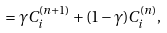<formula> <loc_0><loc_0><loc_500><loc_500>= \gamma C _ { i } ^ { ( n + 1 ) } + ( 1 - \gamma ) C _ { i } ^ { ( n ) } ,</formula> 